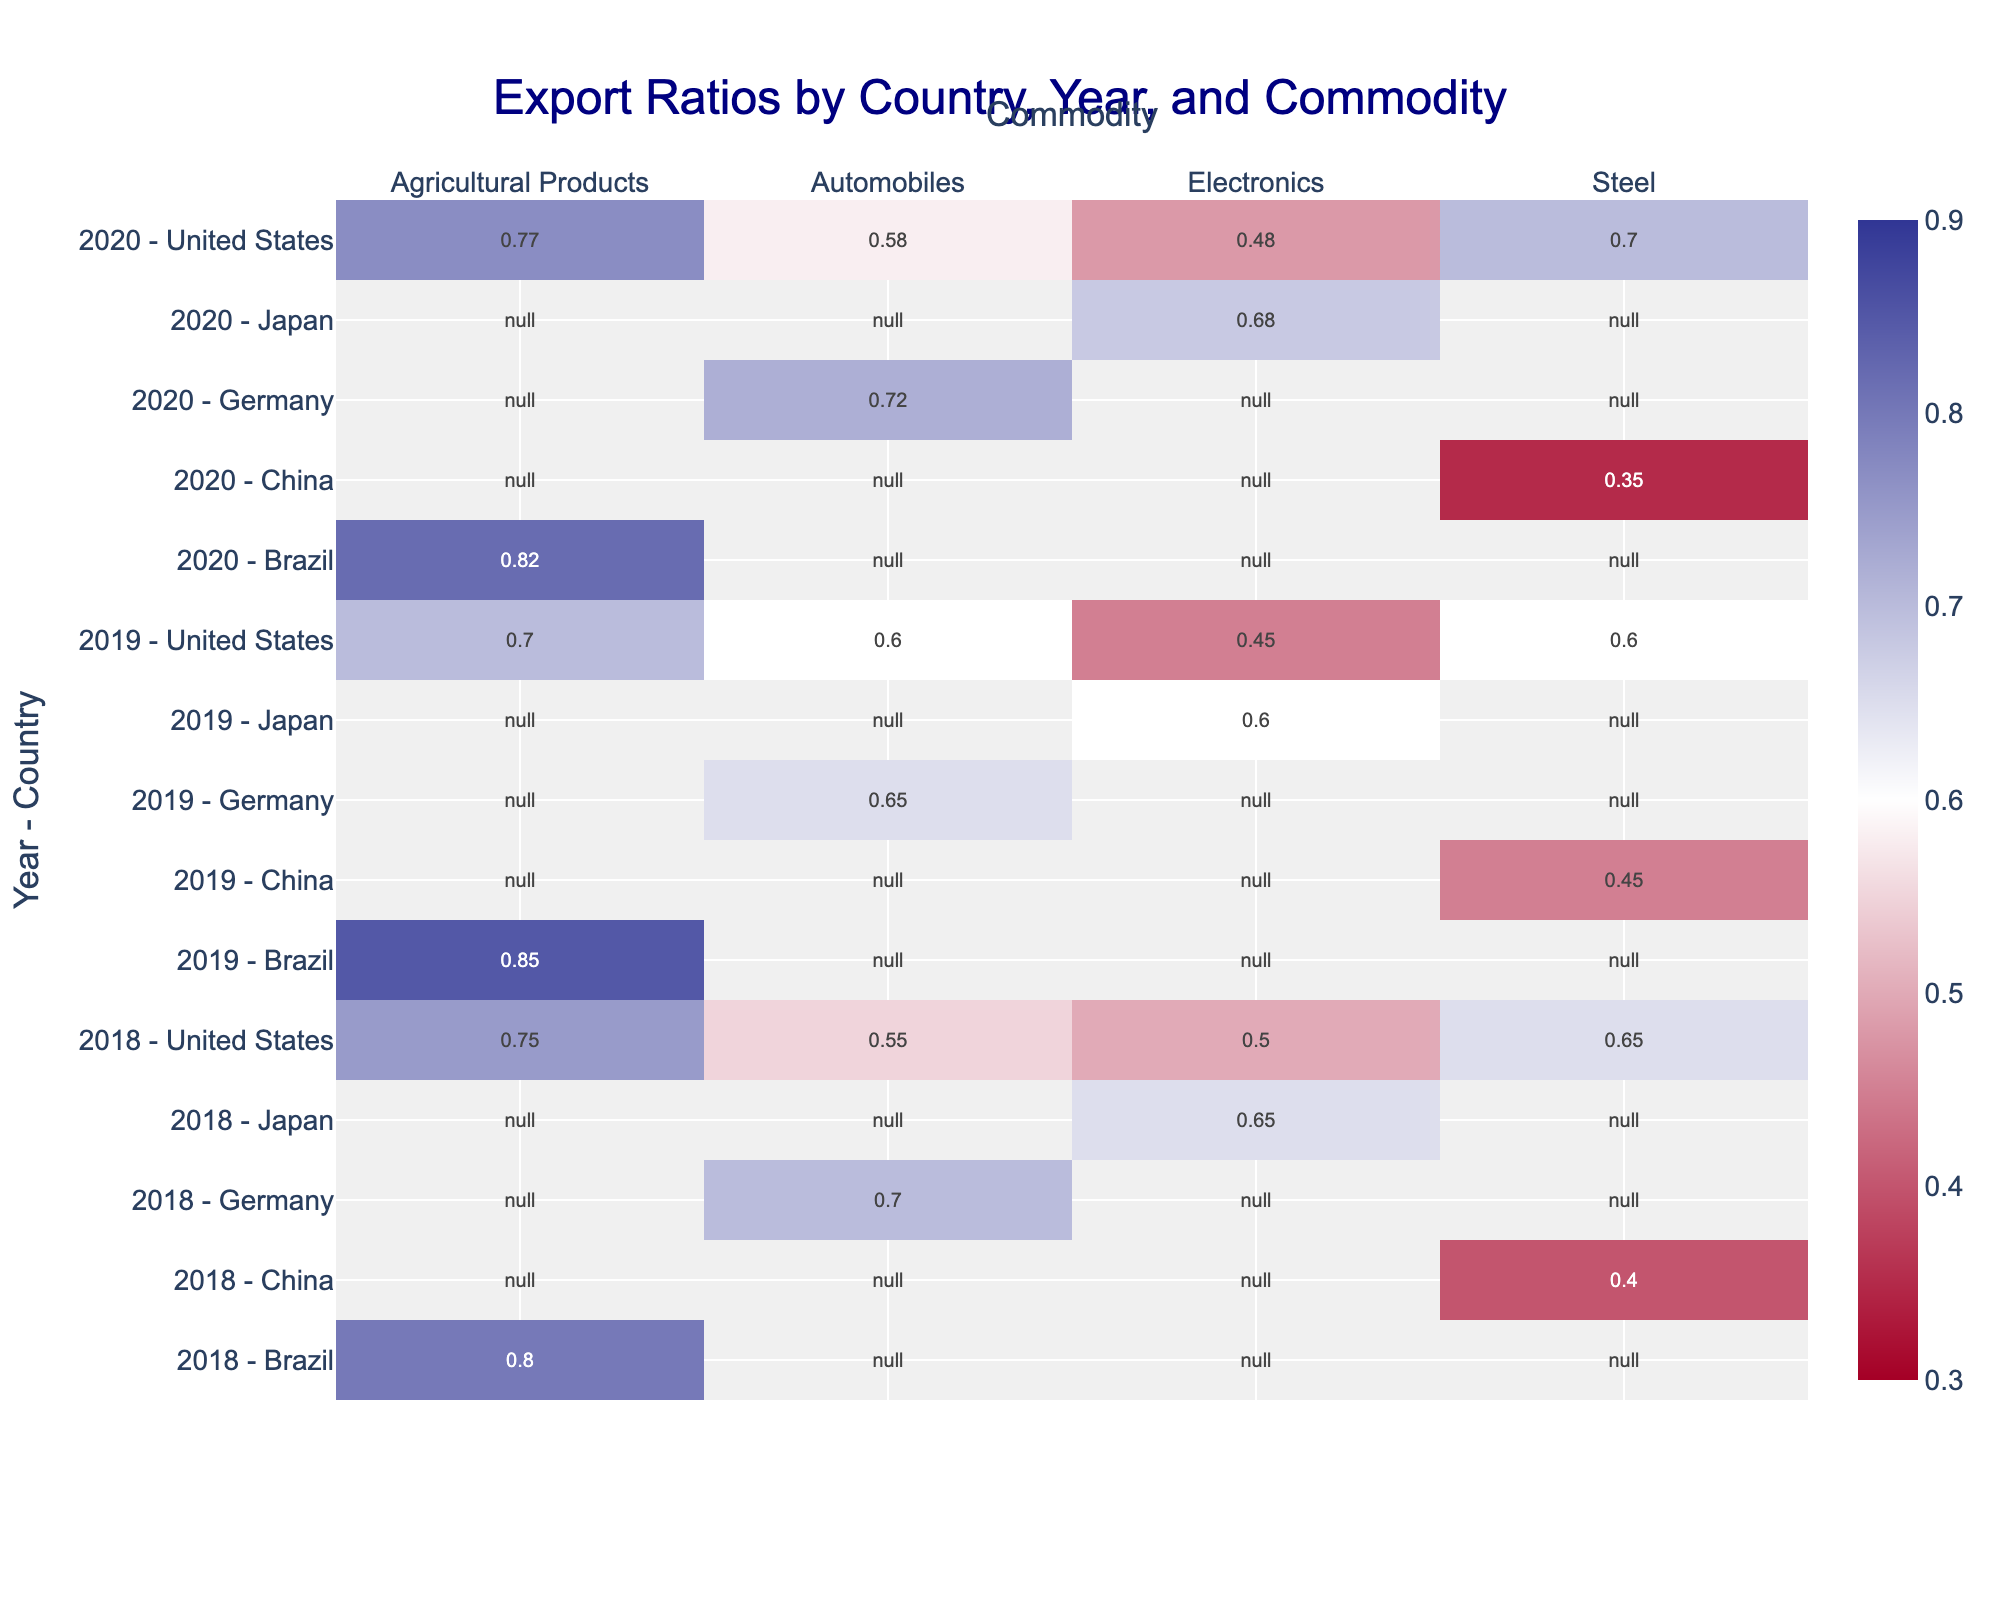What is the title of the heatmap? The title is prominently displayed at the top center of the plot. It reads "Export Ratios by Country, Year, and Commodity".
Answer: Export Ratios by Country, Year, and Commodity Which country has the highest export ratio for electronics in 2020? By looking at the row labeled "2020 - Japan" under the "Electronics" column, we can see the highest export ratio is close to 0.68, which is the highest for that year.
Answer: Japan What is the export ratio for the United States in 2019 for Steel? The row for "2019 - United States" under the "Steel" column shows a value of 0.60.
Answer: 0.60 How did the export ratio for Brazil change for Agricultural Products between 2018 and 2019? The export ratio for Brazil in 2018 for Agricultural Products is 0.80 and it increased to 0.85 in 2019. The change is an increase of 0.05.
Answer: Increased by 0.05 Which commodity had the lowest export ratio for the United States in 2018? Scanning the row labeled "2018 - United States", the lowest value is in the "Electronics" column with 0.50.
Answer: Electronics Compare the export ratios of the United States and Germany for Automobiles in 2019. Which country had a higher ratio? Looking at the row for "2019 - United States" and "2019 - Germany" under the "Automobiles" column, the export ratio for the United States is 0.60 while that for Germany is 0.65. Thus, Germany had a higher ratio.
Answer: Germany What is the average export ratio for the United States across all commodities in 2020? The export ratios for the United States in 2020 are: Steel - 0.70, Automobiles - 0.58, Electronics - 0.48, Agricultural Products - 0.77. The average is calculated as (0.70 + 0.58 + 0.48 + 0.77) / 4 = 0.6325.
Answer: 0.6325 Which year and country combination shows the lowest export ratio for Steel across all years? By examining the "Steel" column, the lowest export ratio is in the row "2020 - China", which is 0.35.
Answer: 2020 - China How did the export ratio for Japan change for Electronics from 2019 to 2020? The export ratio for Japan in the Electronics column is 0.60 in 2019 and 0.68 in 2020, showing an increase of 0.08.
Answer: Increased by 0.08 Which country had a decrease in export ratio for Automobiles in 2020 compared to 2019? By comparing the rows "2019 - Germany" (0.65) and "2020 - Germany" (0.72), there is an increase. But for "2019 - United States" (0.60) and "2020 - United States" (0.58), there's a decrease of 0.02.
Answer: United States 